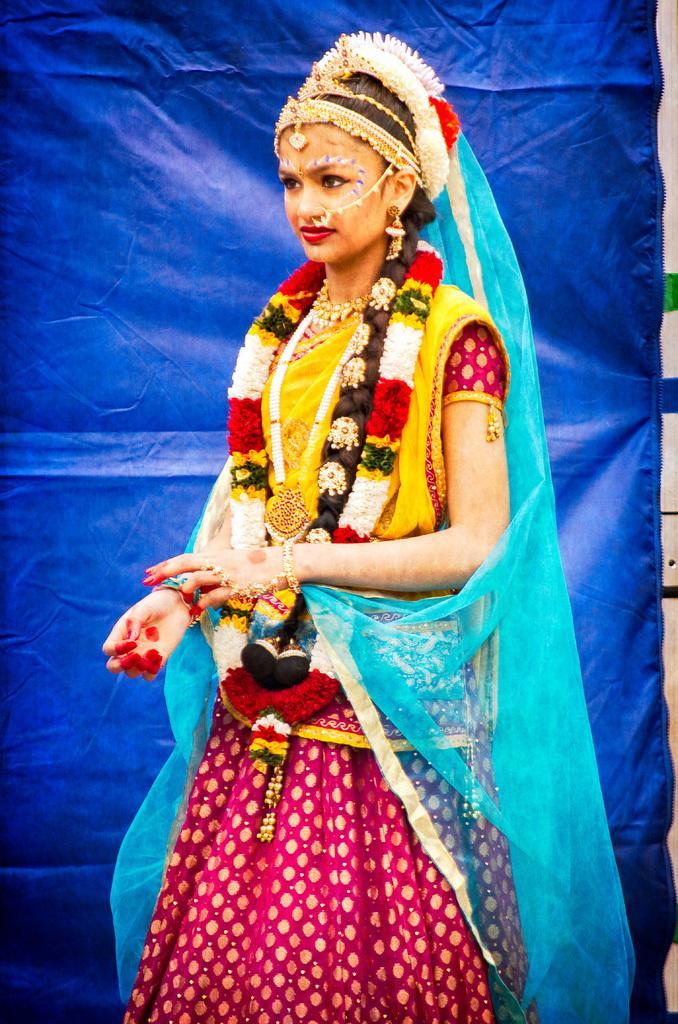How would you summarize this image in a sentence or two? In this image we can see a lady person wearing saree which is in yellow and red in color, also wearing garland of flowers, ornaments and in the background of the image there is blue color sheet. 